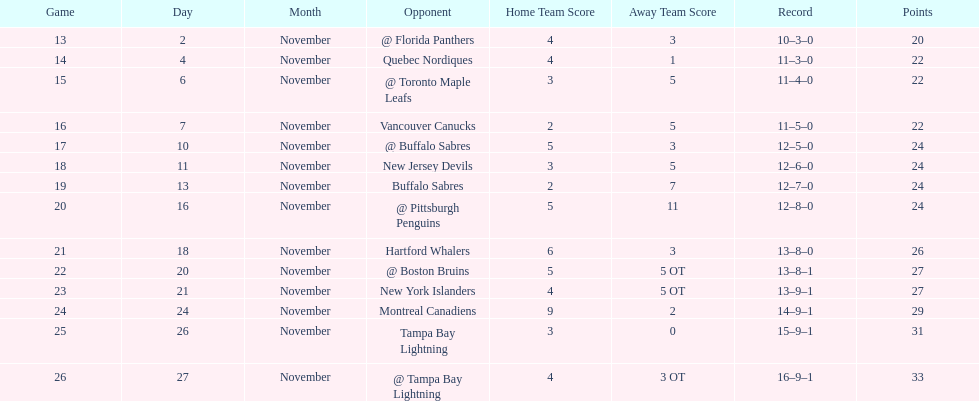Were the new jersey devils in last place according to the chart? No. 